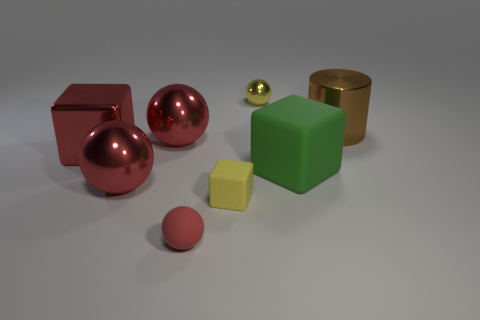What is the material of the big object that is both behind the red block and to the left of the brown cylinder?
Give a very brief answer. Metal. There is a sphere right of the red matte sphere; does it have the same size as the large red metallic block?
Ensure brevity in your answer.  No. Do the tiny rubber block and the tiny shiny sphere have the same color?
Your answer should be compact. Yes. What number of things are behind the tiny red ball and on the left side of the big matte thing?
Your answer should be very brief. 5. There is a red metallic sphere in front of the big cube left of the small block; what number of yellow metallic objects are in front of it?
Your answer should be compact. 0. There is a metallic block that is the same color as the tiny rubber sphere; what is its size?
Ensure brevity in your answer.  Large. The big green object has what shape?
Your answer should be compact. Cube. How many tiny blue cubes have the same material as the green object?
Give a very brief answer. 0. What color is the large cube that is made of the same material as the small cube?
Offer a very short reply. Green. There is a cylinder; is it the same size as the red metallic sphere behind the big green rubber block?
Give a very brief answer. Yes. 